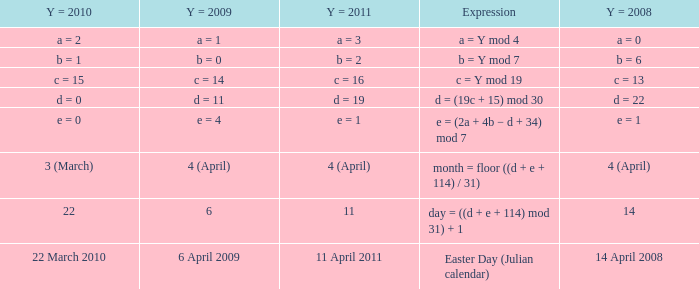What is the y = 2008 when y = 2011 is a = 3? A = 0. 